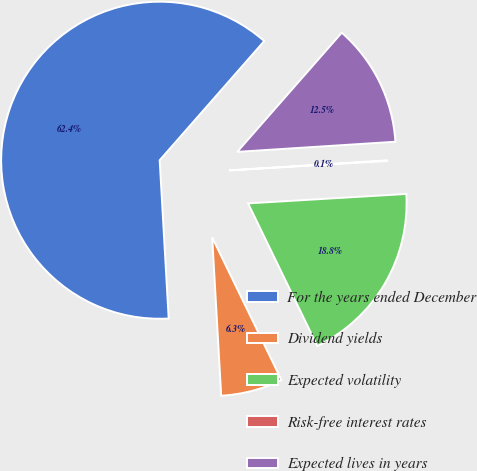Convert chart. <chart><loc_0><loc_0><loc_500><loc_500><pie_chart><fcel>For the years ended December<fcel>Dividend yields<fcel>Expected volatility<fcel>Risk-free interest rates<fcel>Expected lives in years<nl><fcel>62.36%<fcel>6.29%<fcel>18.75%<fcel>0.07%<fcel>12.52%<nl></chart> 